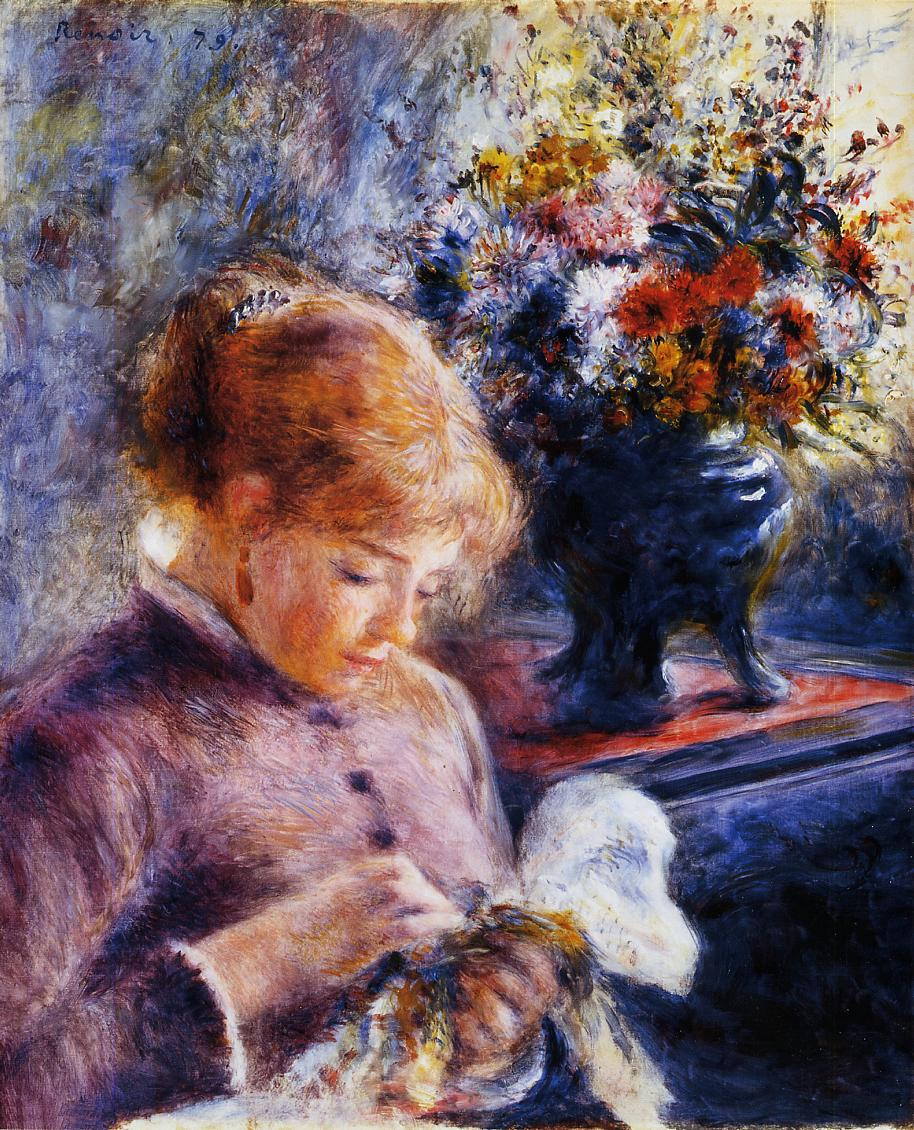Imagine you could step into this painting. What would you hear, smell, and feel? Stepping into this peaceful scene, you might hear the gentle hum of nature outside the window or soft whispers of a breeze carrying the faint chirping of birds. The room itself could be filled with a comforting silence, occasionally punctuated by the subtle sounds of needle and thread. The air would carry the delicate fragrance of fresh flowers from the vibrant bouquet on the table, mingling with the faint, clean scent of the young woman's dress. You would feel a pleasant warmth enveloping you, brought about by the play of soft, warm sunlight filtering through the window. The overall atmosphere would be one of cozy reassurance and meditative focus, inviting you to lose yourself in the tranquil moment. 